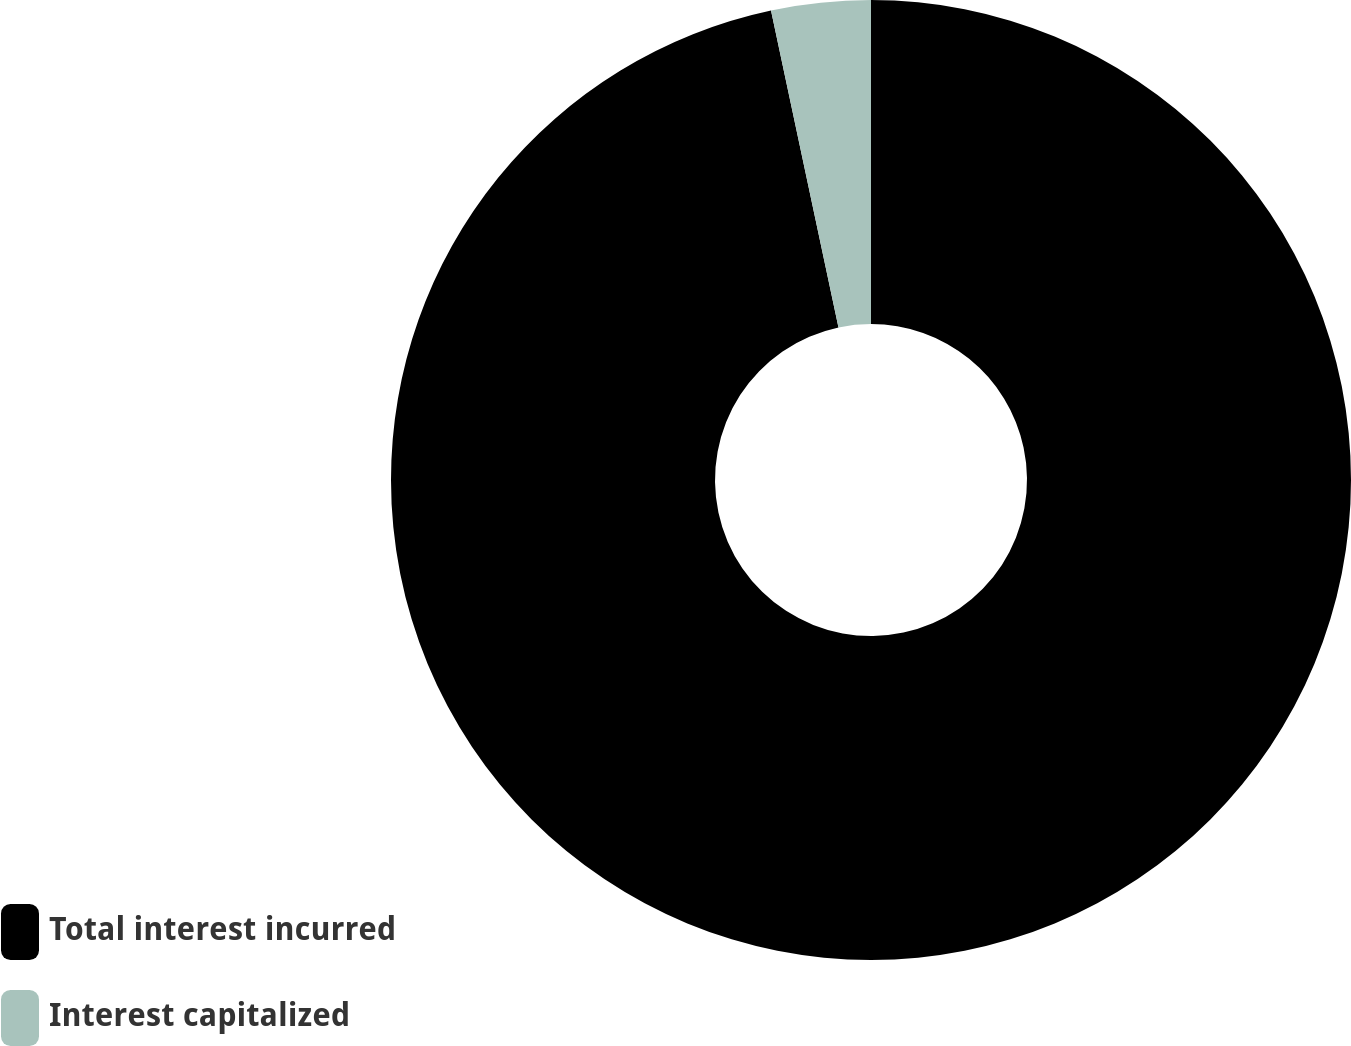Convert chart. <chart><loc_0><loc_0><loc_500><loc_500><pie_chart><fcel>Total interest incurred<fcel>Interest capitalized<nl><fcel>96.66%<fcel>3.34%<nl></chart> 